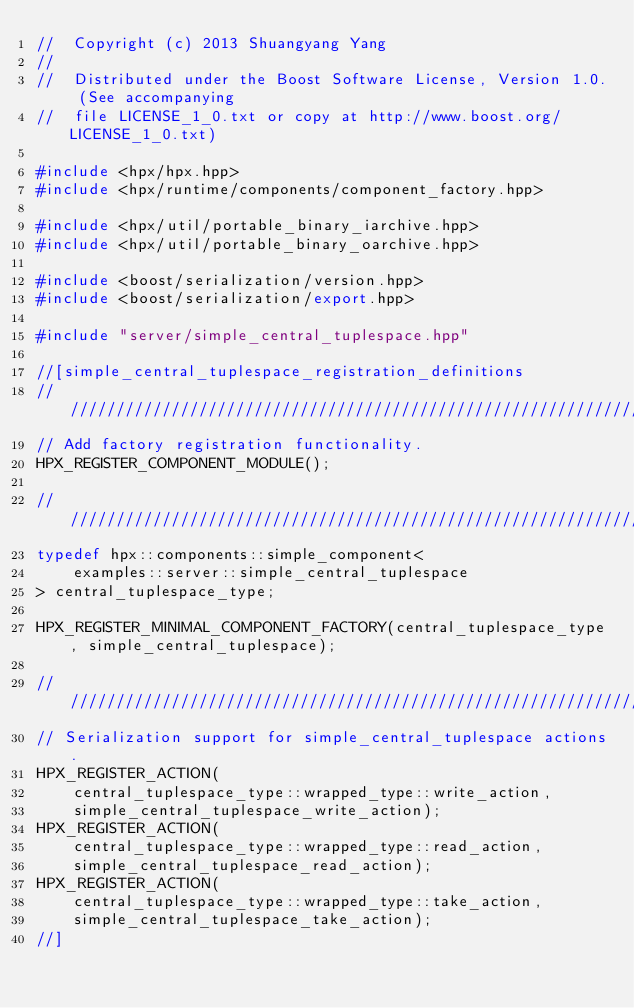<code> <loc_0><loc_0><loc_500><loc_500><_C++_>//  Copyright (c) 2013 Shuangyang Yang
//
//  Distributed under the Boost Software License, Version 1.0. (See accompanying
//  file LICENSE_1_0.txt or copy at http://www.boost.org/LICENSE_1_0.txt)

#include <hpx/hpx.hpp>
#include <hpx/runtime/components/component_factory.hpp>

#include <hpx/util/portable_binary_iarchive.hpp>
#include <hpx/util/portable_binary_oarchive.hpp>

#include <boost/serialization/version.hpp>
#include <boost/serialization/export.hpp>

#include "server/simple_central_tuplespace.hpp"

//[simple_central_tuplespace_registration_definitions
///////////////////////////////////////////////////////////////////////////////
// Add factory registration functionality.
HPX_REGISTER_COMPONENT_MODULE();

///////////////////////////////////////////////////////////////////////////////
typedef hpx::components::simple_component<
    examples::server::simple_central_tuplespace
> central_tuplespace_type;

HPX_REGISTER_MINIMAL_COMPONENT_FACTORY(central_tuplespace_type, simple_central_tuplespace);

///////////////////////////////////////////////////////////////////////////////
// Serialization support for simple_central_tuplespace actions.
HPX_REGISTER_ACTION(
    central_tuplespace_type::wrapped_type::write_action,
    simple_central_tuplespace_write_action);
HPX_REGISTER_ACTION(
    central_tuplespace_type::wrapped_type::read_action,
    simple_central_tuplespace_read_action);
HPX_REGISTER_ACTION(
    central_tuplespace_type::wrapped_type::take_action,
    simple_central_tuplespace_take_action);
//]

</code> 